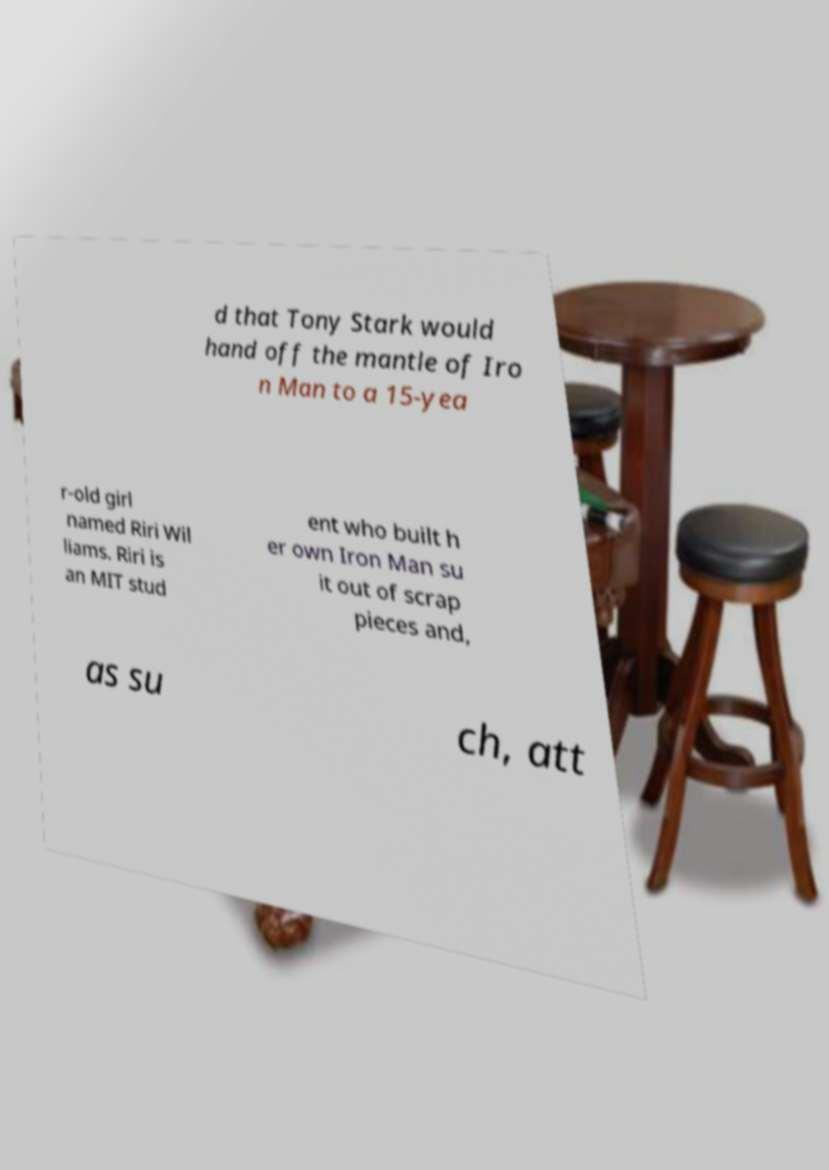For documentation purposes, I need the text within this image transcribed. Could you provide that? d that Tony Stark would hand off the mantle of Iro n Man to a 15-yea r-old girl named Riri Wil liams. Riri is an MIT stud ent who built h er own Iron Man su it out of scrap pieces and, as su ch, att 